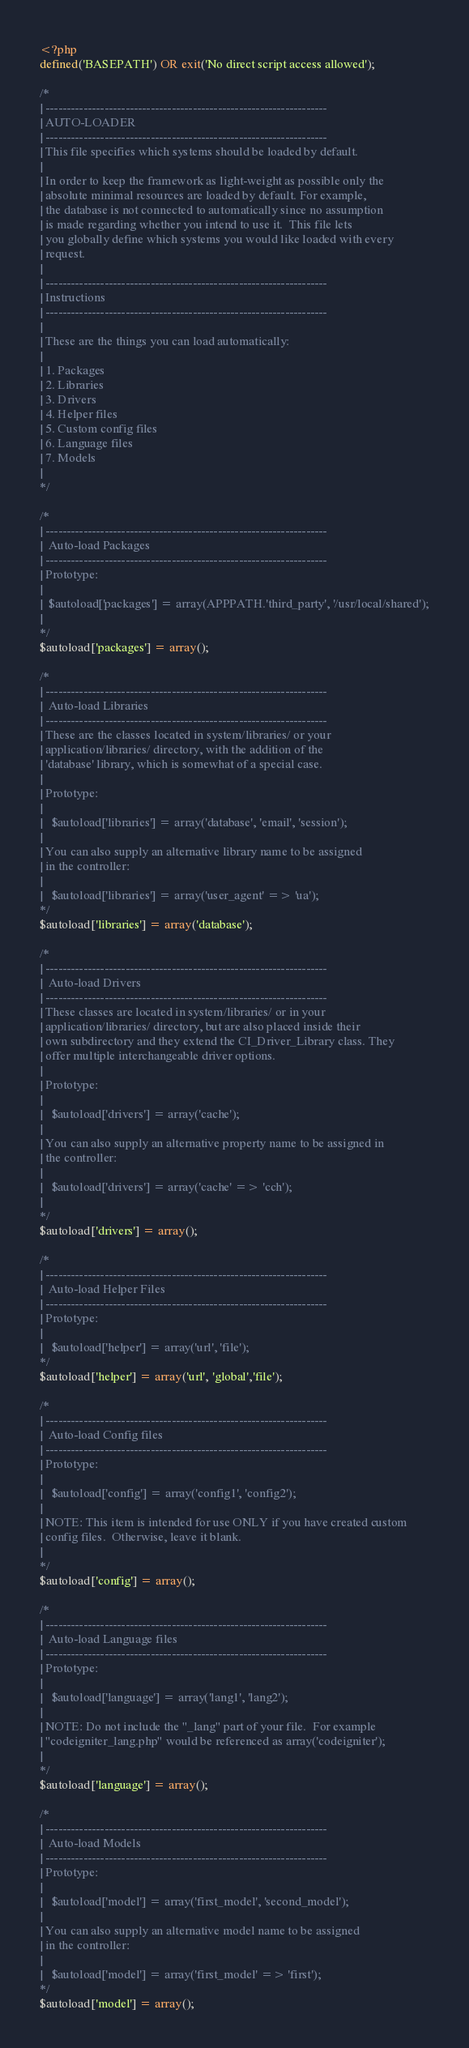<code> <loc_0><loc_0><loc_500><loc_500><_PHP_><?php
defined('BASEPATH') OR exit('No direct script access allowed');

/*
| -------------------------------------------------------------------
| AUTO-LOADER
| -------------------------------------------------------------------
| This file specifies which systems should be loaded by default.
|
| In order to keep the framework as light-weight as possible only the
| absolute minimal resources are loaded by default. For example,
| the database is not connected to automatically since no assumption
| is made regarding whether you intend to use it.  This file lets
| you globally define which systems you would like loaded with every
| request.
|
| -------------------------------------------------------------------
| Instructions
| -------------------------------------------------------------------
|
| These are the things you can load automatically:
|
| 1. Packages
| 2. Libraries
| 3. Drivers
| 4. Helper files
| 5. Custom config files
| 6. Language files
| 7. Models
|
*/

/*
| -------------------------------------------------------------------
|  Auto-load Packages
| -------------------------------------------------------------------
| Prototype:
|
|  $autoload['packages'] = array(APPPATH.'third_party', '/usr/local/shared');
|
*/
$autoload['packages'] = array();

/*
| -------------------------------------------------------------------
|  Auto-load Libraries
| -------------------------------------------------------------------
| These are the classes located in system/libraries/ or your
| application/libraries/ directory, with the addition of the
| 'database' library, which is somewhat of a special case.
|
| Prototype:
|
|	$autoload['libraries'] = array('database', 'email', 'session');
|
| You can also supply an alternative library name to be assigned
| in the controller:
|
|	$autoload['libraries'] = array('user_agent' => 'ua');
*/
$autoload['libraries'] = array('database');

/*
| -------------------------------------------------------------------
|  Auto-load Drivers
| -------------------------------------------------------------------
| These classes are located in system/libraries/ or in your
| application/libraries/ directory, but are also placed inside their
| own subdirectory and they extend the CI_Driver_Library class. They
| offer multiple interchangeable driver options.
|
| Prototype:
|
|	$autoload['drivers'] = array('cache');
|
| You can also supply an alternative property name to be assigned in
| the controller:
|
|	$autoload['drivers'] = array('cache' => 'cch');
|
*/
$autoload['drivers'] = array();

/*
| -------------------------------------------------------------------
|  Auto-load Helper Files
| -------------------------------------------------------------------
| Prototype:
|
|	$autoload['helper'] = array('url', 'file');
*/
$autoload['helper'] = array('url', 'global','file');

/*
| -------------------------------------------------------------------
|  Auto-load Config files
| -------------------------------------------------------------------
| Prototype:
|
|	$autoload['config'] = array('config1', 'config2');
|
| NOTE: This item is intended for use ONLY if you have created custom
| config files.  Otherwise, leave it blank.
|
*/
$autoload['config'] = array();

/*
| -------------------------------------------------------------------
|  Auto-load Language files
| -------------------------------------------------------------------
| Prototype:
|
|	$autoload['language'] = array('lang1', 'lang2');
|
| NOTE: Do not include the "_lang" part of your file.  For example
| "codeigniter_lang.php" would be referenced as array('codeigniter');
|
*/
$autoload['language'] = array();

/*
| -------------------------------------------------------------------
|  Auto-load Models
| -------------------------------------------------------------------
| Prototype:
|
|	$autoload['model'] = array('first_model', 'second_model');
|
| You can also supply an alternative model name to be assigned
| in the controller:
|
|	$autoload['model'] = array('first_model' => 'first');
*/
$autoload['model'] = array();
</code> 